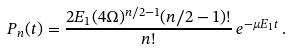Convert formula to latex. <formula><loc_0><loc_0><loc_500><loc_500>P _ { n } ( t ) = \frac { 2 E _ { 1 } ( 4 \Omega ) ^ { n / 2 - 1 } ( n / 2 - 1 ) ! } { n ! } \, e ^ { - \mu E _ { 1 } t } \, .</formula> 